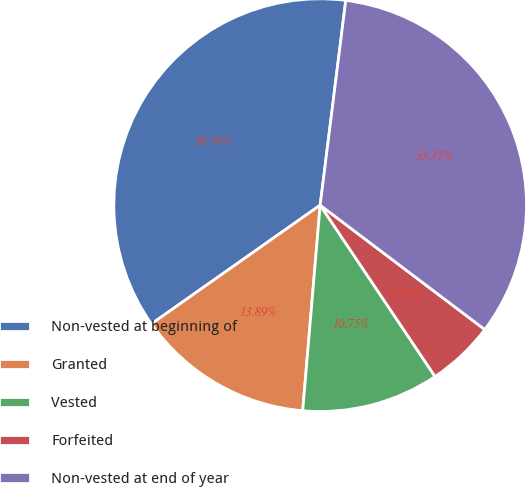Convert chart. <chart><loc_0><loc_0><loc_500><loc_500><pie_chart><fcel>Non-vested at beginning of<fcel>Granted<fcel>Vested<fcel>Forfeited<fcel>Non-vested at end of year<nl><fcel>36.74%<fcel>13.89%<fcel>10.75%<fcel>5.3%<fcel>33.32%<nl></chart> 